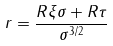Convert formula to latex. <formula><loc_0><loc_0><loc_500><loc_500>r = { \frac { R \xi \sigma + R \tau } { \sigma ^ { 3 / 2 } } }</formula> 